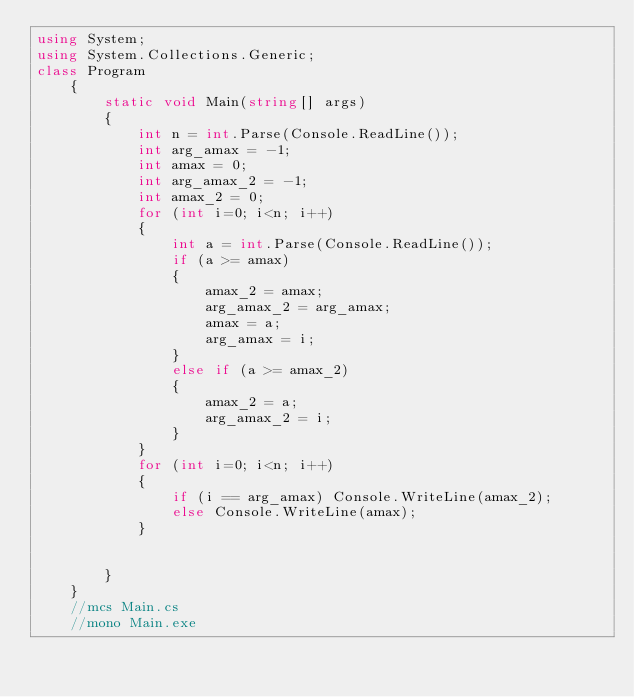Convert code to text. <code><loc_0><loc_0><loc_500><loc_500><_C#_>using System;
using System.Collections.Generic;
class Program
    {
        static void Main(string[] args)
        {
            int n = int.Parse(Console.ReadLine());
            int arg_amax = -1;
            int amax = 0;
            int arg_amax_2 = -1;
            int amax_2 = 0;
            for (int i=0; i<n; i++)
            {
                int a = int.Parse(Console.ReadLine());
                if (a >= amax)
                {
                    amax_2 = amax;
                    arg_amax_2 = arg_amax;
                    amax = a;
                    arg_amax = i;
                }
                else if (a >= amax_2)
                {
                    amax_2 = a;
                    arg_amax_2 = i;
                }
            }
            for (int i=0; i<n; i++)
            {
                if (i == arg_amax) Console.WriteLine(amax_2);
                else Console.WriteLine(amax);
            }

            
        }
    }
    //mcs Main.cs
    //mono Main.exe</code> 